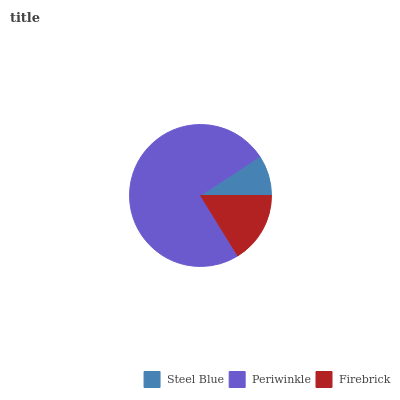Is Steel Blue the minimum?
Answer yes or no. Yes. Is Periwinkle the maximum?
Answer yes or no. Yes. Is Firebrick the minimum?
Answer yes or no. No. Is Firebrick the maximum?
Answer yes or no. No. Is Periwinkle greater than Firebrick?
Answer yes or no. Yes. Is Firebrick less than Periwinkle?
Answer yes or no. Yes. Is Firebrick greater than Periwinkle?
Answer yes or no. No. Is Periwinkle less than Firebrick?
Answer yes or no. No. Is Firebrick the high median?
Answer yes or no. Yes. Is Firebrick the low median?
Answer yes or no. Yes. Is Steel Blue the high median?
Answer yes or no. No. Is Periwinkle the low median?
Answer yes or no. No. 